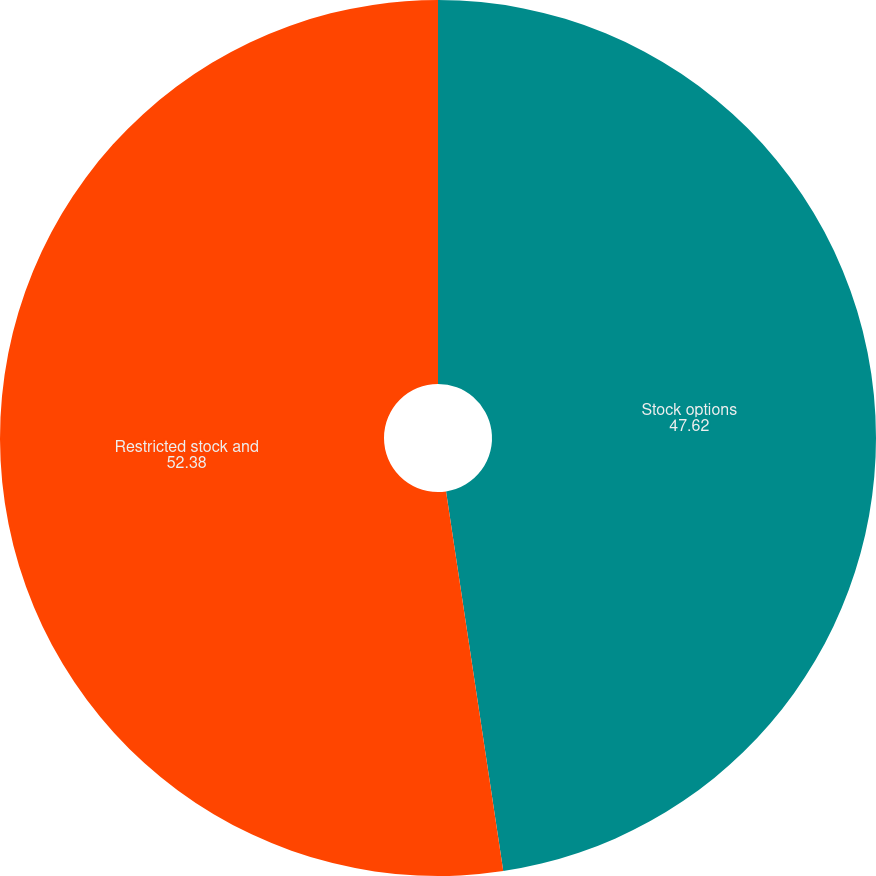<chart> <loc_0><loc_0><loc_500><loc_500><pie_chart><fcel>Stock options<fcel>Restricted stock and<nl><fcel>47.62%<fcel>52.38%<nl></chart> 